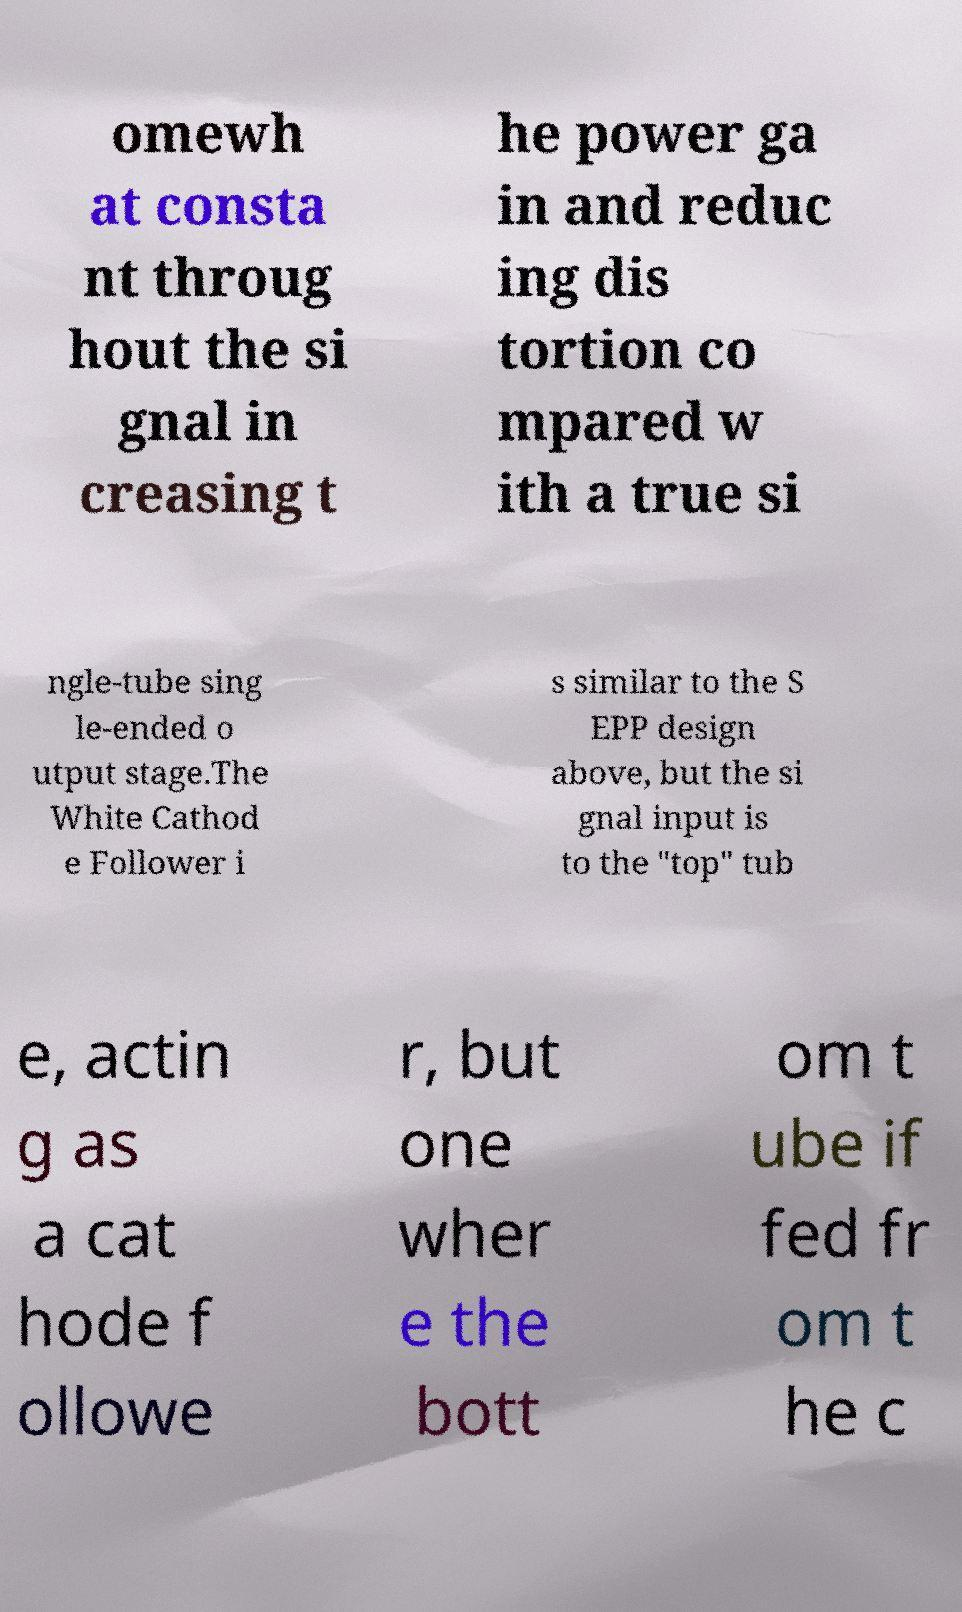For documentation purposes, I need the text within this image transcribed. Could you provide that? omewh at consta nt throug hout the si gnal in creasing t he power ga in and reduc ing dis tortion co mpared w ith a true si ngle-tube sing le-ended o utput stage.The White Cathod e Follower i s similar to the S EPP design above, but the si gnal input is to the "top" tub e, actin g as a cat hode f ollowe r, but one wher e the bott om t ube if fed fr om t he c 